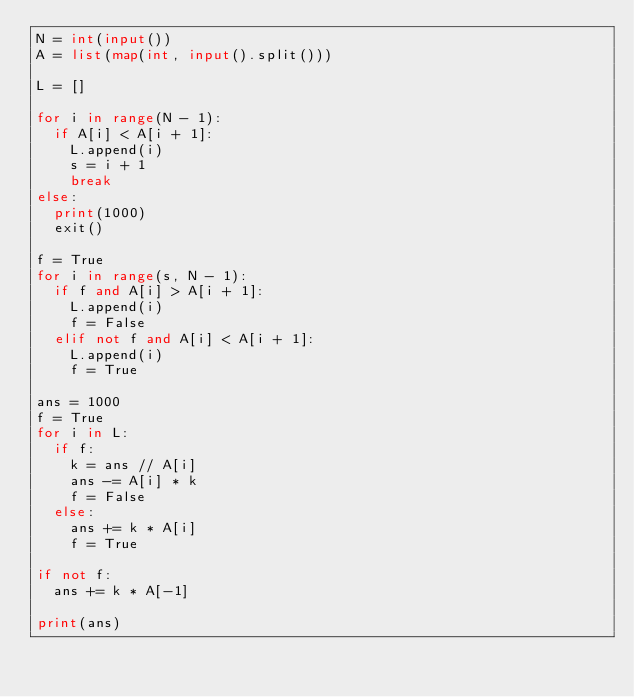Convert code to text. <code><loc_0><loc_0><loc_500><loc_500><_Python_>N = int(input())
A = list(map(int, input().split()))

L = []

for i in range(N - 1):
  if A[i] < A[i + 1]:
    L.append(i)
    s = i + 1
    break
else:
  print(1000)
  exit()

f = True
for i in range(s, N - 1):
  if f and A[i] > A[i + 1]:
    L.append(i)
    f = False
  elif not f and A[i] < A[i + 1]:
    L.append(i)
    f = True

ans = 1000
f = True
for i in L:
  if f:
    k = ans // A[i]
    ans -= A[i] * k
    f = False
  else:
    ans += k * A[i]
    f = True

if not f:
  ans += k * A[-1]

print(ans)

</code> 